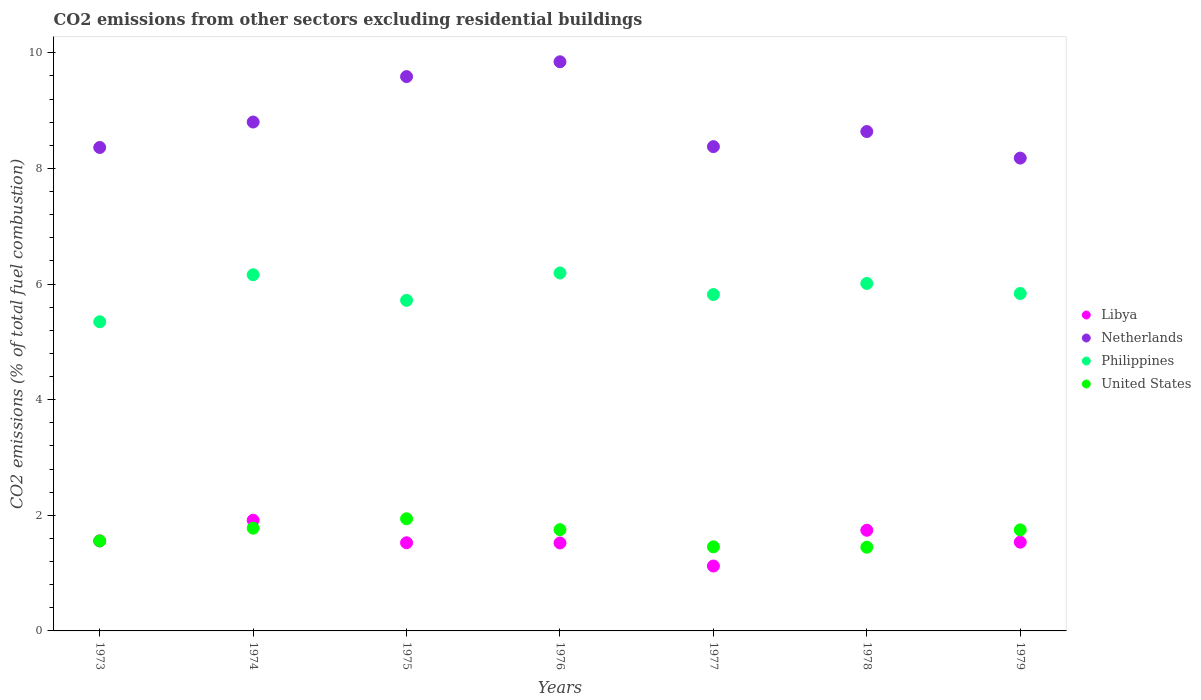Is the number of dotlines equal to the number of legend labels?
Provide a short and direct response. Yes. What is the total CO2 emitted in United States in 1978?
Keep it short and to the point. 1.45. Across all years, what is the maximum total CO2 emitted in Philippines?
Your response must be concise. 6.19. Across all years, what is the minimum total CO2 emitted in United States?
Provide a short and direct response. 1.45. In which year was the total CO2 emitted in Netherlands maximum?
Provide a succinct answer. 1976. What is the total total CO2 emitted in Libya in the graph?
Offer a terse response. 10.92. What is the difference between the total CO2 emitted in Libya in 1974 and that in 1977?
Offer a terse response. 0.79. What is the difference between the total CO2 emitted in Netherlands in 1973 and the total CO2 emitted in Philippines in 1974?
Your answer should be compact. 2.2. What is the average total CO2 emitted in Libya per year?
Offer a very short reply. 1.56. In the year 1974, what is the difference between the total CO2 emitted in Philippines and total CO2 emitted in United States?
Offer a very short reply. 4.38. What is the ratio of the total CO2 emitted in Philippines in 1973 to that in 1976?
Make the answer very short. 0.86. Is the total CO2 emitted in Philippines in 1975 less than that in 1979?
Your answer should be compact. Yes. Is the difference between the total CO2 emitted in Philippines in 1973 and 1975 greater than the difference between the total CO2 emitted in United States in 1973 and 1975?
Your answer should be very brief. Yes. What is the difference between the highest and the second highest total CO2 emitted in United States?
Your response must be concise. 0.16. What is the difference between the highest and the lowest total CO2 emitted in Philippines?
Offer a terse response. 0.84. In how many years, is the total CO2 emitted in Libya greater than the average total CO2 emitted in Libya taken over all years?
Provide a succinct answer. 2. Is the sum of the total CO2 emitted in Libya in 1977 and 1979 greater than the maximum total CO2 emitted in Philippines across all years?
Your response must be concise. No. Is it the case that in every year, the sum of the total CO2 emitted in Netherlands and total CO2 emitted in United States  is greater than the total CO2 emitted in Philippines?
Keep it short and to the point. Yes. Is the total CO2 emitted in Netherlands strictly greater than the total CO2 emitted in United States over the years?
Make the answer very short. Yes. Is the total CO2 emitted in Libya strictly less than the total CO2 emitted in United States over the years?
Offer a terse response. No. Does the graph contain any zero values?
Your response must be concise. No. How are the legend labels stacked?
Offer a terse response. Vertical. What is the title of the graph?
Your response must be concise. CO2 emissions from other sectors excluding residential buildings. What is the label or title of the Y-axis?
Provide a succinct answer. CO2 emissions (% of total fuel combustion). What is the CO2 emissions (% of total fuel combustion) in Libya in 1973?
Ensure brevity in your answer.  1.56. What is the CO2 emissions (% of total fuel combustion) in Netherlands in 1973?
Offer a very short reply. 8.36. What is the CO2 emissions (% of total fuel combustion) in Philippines in 1973?
Your answer should be very brief. 5.35. What is the CO2 emissions (% of total fuel combustion) of United States in 1973?
Offer a terse response. 1.56. What is the CO2 emissions (% of total fuel combustion) of Libya in 1974?
Offer a terse response. 1.91. What is the CO2 emissions (% of total fuel combustion) in Netherlands in 1974?
Ensure brevity in your answer.  8.8. What is the CO2 emissions (% of total fuel combustion) in Philippines in 1974?
Keep it short and to the point. 6.16. What is the CO2 emissions (% of total fuel combustion) in United States in 1974?
Ensure brevity in your answer.  1.78. What is the CO2 emissions (% of total fuel combustion) in Libya in 1975?
Your response must be concise. 1.53. What is the CO2 emissions (% of total fuel combustion) of Netherlands in 1975?
Offer a terse response. 9.59. What is the CO2 emissions (% of total fuel combustion) of Philippines in 1975?
Provide a succinct answer. 5.72. What is the CO2 emissions (% of total fuel combustion) of United States in 1975?
Your response must be concise. 1.94. What is the CO2 emissions (% of total fuel combustion) of Libya in 1976?
Give a very brief answer. 1.52. What is the CO2 emissions (% of total fuel combustion) of Netherlands in 1976?
Your response must be concise. 9.85. What is the CO2 emissions (% of total fuel combustion) of Philippines in 1976?
Provide a succinct answer. 6.19. What is the CO2 emissions (% of total fuel combustion) in United States in 1976?
Your answer should be very brief. 1.75. What is the CO2 emissions (% of total fuel combustion) in Libya in 1977?
Offer a terse response. 1.12. What is the CO2 emissions (% of total fuel combustion) of Netherlands in 1977?
Give a very brief answer. 8.38. What is the CO2 emissions (% of total fuel combustion) in Philippines in 1977?
Offer a terse response. 5.82. What is the CO2 emissions (% of total fuel combustion) of United States in 1977?
Your answer should be very brief. 1.45. What is the CO2 emissions (% of total fuel combustion) of Libya in 1978?
Give a very brief answer. 1.74. What is the CO2 emissions (% of total fuel combustion) in Netherlands in 1978?
Provide a short and direct response. 8.64. What is the CO2 emissions (% of total fuel combustion) in Philippines in 1978?
Make the answer very short. 6.01. What is the CO2 emissions (% of total fuel combustion) of United States in 1978?
Offer a terse response. 1.45. What is the CO2 emissions (% of total fuel combustion) in Libya in 1979?
Keep it short and to the point. 1.54. What is the CO2 emissions (% of total fuel combustion) in Netherlands in 1979?
Give a very brief answer. 8.18. What is the CO2 emissions (% of total fuel combustion) of Philippines in 1979?
Keep it short and to the point. 5.84. What is the CO2 emissions (% of total fuel combustion) of United States in 1979?
Make the answer very short. 1.75. Across all years, what is the maximum CO2 emissions (% of total fuel combustion) of Libya?
Provide a succinct answer. 1.91. Across all years, what is the maximum CO2 emissions (% of total fuel combustion) of Netherlands?
Your response must be concise. 9.85. Across all years, what is the maximum CO2 emissions (% of total fuel combustion) in Philippines?
Your response must be concise. 6.19. Across all years, what is the maximum CO2 emissions (% of total fuel combustion) in United States?
Your answer should be very brief. 1.94. Across all years, what is the minimum CO2 emissions (% of total fuel combustion) of Libya?
Provide a short and direct response. 1.12. Across all years, what is the minimum CO2 emissions (% of total fuel combustion) of Netherlands?
Provide a succinct answer. 8.18. Across all years, what is the minimum CO2 emissions (% of total fuel combustion) of Philippines?
Offer a terse response. 5.35. Across all years, what is the minimum CO2 emissions (% of total fuel combustion) of United States?
Provide a succinct answer. 1.45. What is the total CO2 emissions (% of total fuel combustion) in Libya in the graph?
Offer a terse response. 10.92. What is the total CO2 emissions (% of total fuel combustion) in Netherlands in the graph?
Give a very brief answer. 61.8. What is the total CO2 emissions (% of total fuel combustion) of Philippines in the graph?
Keep it short and to the point. 41.09. What is the total CO2 emissions (% of total fuel combustion) of United States in the graph?
Your response must be concise. 11.68. What is the difference between the CO2 emissions (% of total fuel combustion) of Libya in 1973 and that in 1974?
Give a very brief answer. -0.36. What is the difference between the CO2 emissions (% of total fuel combustion) in Netherlands in 1973 and that in 1974?
Give a very brief answer. -0.44. What is the difference between the CO2 emissions (% of total fuel combustion) of Philippines in 1973 and that in 1974?
Give a very brief answer. -0.81. What is the difference between the CO2 emissions (% of total fuel combustion) in United States in 1973 and that in 1974?
Your answer should be very brief. -0.22. What is the difference between the CO2 emissions (% of total fuel combustion) of Libya in 1973 and that in 1975?
Provide a short and direct response. 0.03. What is the difference between the CO2 emissions (% of total fuel combustion) in Netherlands in 1973 and that in 1975?
Offer a very short reply. -1.23. What is the difference between the CO2 emissions (% of total fuel combustion) in Philippines in 1973 and that in 1975?
Keep it short and to the point. -0.37. What is the difference between the CO2 emissions (% of total fuel combustion) in United States in 1973 and that in 1975?
Ensure brevity in your answer.  -0.38. What is the difference between the CO2 emissions (% of total fuel combustion) of Libya in 1973 and that in 1976?
Your answer should be compact. 0.04. What is the difference between the CO2 emissions (% of total fuel combustion) of Netherlands in 1973 and that in 1976?
Your answer should be compact. -1.48. What is the difference between the CO2 emissions (% of total fuel combustion) in Philippines in 1973 and that in 1976?
Make the answer very short. -0.84. What is the difference between the CO2 emissions (% of total fuel combustion) in United States in 1973 and that in 1976?
Provide a short and direct response. -0.19. What is the difference between the CO2 emissions (% of total fuel combustion) of Libya in 1973 and that in 1977?
Your response must be concise. 0.43. What is the difference between the CO2 emissions (% of total fuel combustion) of Netherlands in 1973 and that in 1977?
Give a very brief answer. -0.01. What is the difference between the CO2 emissions (% of total fuel combustion) in Philippines in 1973 and that in 1977?
Provide a succinct answer. -0.47. What is the difference between the CO2 emissions (% of total fuel combustion) of United States in 1973 and that in 1977?
Keep it short and to the point. 0.1. What is the difference between the CO2 emissions (% of total fuel combustion) in Libya in 1973 and that in 1978?
Your response must be concise. -0.18. What is the difference between the CO2 emissions (% of total fuel combustion) in Netherlands in 1973 and that in 1978?
Your answer should be very brief. -0.28. What is the difference between the CO2 emissions (% of total fuel combustion) of Philippines in 1973 and that in 1978?
Give a very brief answer. -0.66. What is the difference between the CO2 emissions (% of total fuel combustion) of United States in 1973 and that in 1978?
Keep it short and to the point. 0.11. What is the difference between the CO2 emissions (% of total fuel combustion) of Libya in 1973 and that in 1979?
Provide a short and direct response. 0.02. What is the difference between the CO2 emissions (% of total fuel combustion) of Netherlands in 1973 and that in 1979?
Your answer should be compact. 0.18. What is the difference between the CO2 emissions (% of total fuel combustion) in Philippines in 1973 and that in 1979?
Ensure brevity in your answer.  -0.49. What is the difference between the CO2 emissions (% of total fuel combustion) of United States in 1973 and that in 1979?
Keep it short and to the point. -0.19. What is the difference between the CO2 emissions (% of total fuel combustion) of Libya in 1974 and that in 1975?
Offer a terse response. 0.39. What is the difference between the CO2 emissions (% of total fuel combustion) in Netherlands in 1974 and that in 1975?
Your answer should be very brief. -0.79. What is the difference between the CO2 emissions (% of total fuel combustion) of Philippines in 1974 and that in 1975?
Your answer should be very brief. 0.44. What is the difference between the CO2 emissions (% of total fuel combustion) of United States in 1974 and that in 1975?
Provide a short and direct response. -0.16. What is the difference between the CO2 emissions (% of total fuel combustion) of Libya in 1974 and that in 1976?
Your answer should be compact. 0.39. What is the difference between the CO2 emissions (% of total fuel combustion) of Netherlands in 1974 and that in 1976?
Your answer should be very brief. -1.04. What is the difference between the CO2 emissions (% of total fuel combustion) of Philippines in 1974 and that in 1976?
Your response must be concise. -0.03. What is the difference between the CO2 emissions (% of total fuel combustion) of United States in 1974 and that in 1976?
Provide a succinct answer. 0.03. What is the difference between the CO2 emissions (% of total fuel combustion) in Libya in 1974 and that in 1977?
Your response must be concise. 0.79. What is the difference between the CO2 emissions (% of total fuel combustion) in Netherlands in 1974 and that in 1977?
Keep it short and to the point. 0.43. What is the difference between the CO2 emissions (% of total fuel combustion) of Philippines in 1974 and that in 1977?
Give a very brief answer. 0.34. What is the difference between the CO2 emissions (% of total fuel combustion) of United States in 1974 and that in 1977?
Offer a very short reply. 0.32. What is the difference between the CO2 emissions (% of total fuel combustion) of Libya in 1974 and that in 1978?
Ensure brevity in your answer.  0.17. What is the difference between the CO2 emissions (% of total fuel combustion) in Netherlands in 1974 and that in 1978?
Give a very brief answer. 0.16. What is the difference between the CO2 emissions (% of total fuel combustion) of Philippines in 1974 and that in 1978?
Ensure brevity in your answer.  0.15. What is the difference between the CO2 emissions (% of total fuel combustion) of United States in 1974 and that in 1978?
Offer a very short reply. 0.33. What is the difference between the CO2 emissions (% of total fuel combustion) in Libya in 1974 and that in 1979?
Provide a short and direct response. 0.38. What is the difference between the CO2 emissions (% of total fuel combustion) in Netherlands in 1974 and that in 1979?
Give a very brief answer. 0.62. What is the difference between the CO2 emissions (% of total fuel combustion) of Philippines in 1974 and that in 1979?
Keep it short and to the point. 0.32. What is the difference between the CO2 emissions (% of total fuel combustion) of United States in 1974 and that in 1979?
Give a very brief answer. 0.03. What is the difference between the CO2 emissions (% of total fuel combustion) in Libya in 1975 and that in 1976?
Make the answer very short. 0. What is the difference between the CO2 emissions (% of total fuel combustion) of Netherlands in 1975 and that in 1976?
Ensure brevity in your answer.  -0.26. What is the difference between the CO2 emissions (% of total fuel combustion) of Philippines in 1975 and that in 1976?
Your response must be concise. -0.47. What is the difference between the CO2 emissions (% of total fuel combustion) of United States in 1975 and that in 1976?
Keep it short and to the point. 0.19. What is the difference between the CO2 emissions (% of total fuel combustion) of Libya in 1975 and that in 1977?
Give a very brief answer. 0.4. What is the difference between the CO2 emissions (% of total fuel combustion) of Netherlands in 1975 and that in 1977?
Ensure brevity in your answer.  1.21. What is the difference between the CO2 emissions (% of total fuel combustion) of Philippines in 1975 and that in 1977?
Your answer should be very brief. -0.1. What is the difference between the CO2 emissions (% of total fuel combustion) in United States in 1975 and that in 1977?
Your response must be concise. 0.49. What is the difference between the CO2 emissions (% of total fuel combustion) in Libya in 1975 and that in 1978?
Provide a short and direct response. -0.22. What is the difference between the CO2 emissions (% of total fuel combustion) in Netherlands in 1975 and that in 1978?
Provide a short and direct response. 0.95. What is the difference between the CO2 emissions (% of total fuel combustion) in Philippines in 1975 and that in 1978?
Provide a short and direct response. -0.29. What is the difference between the CO2 emissions (% of total fuel combustion) of United States in 1975 and that in 1978?
Keep it short and to the point. 0.49. What is the difference between the CO2 emissions (% of total fuel combustion) in Libya in 1975 and that in 1979?
Provide a succinct answer. -0.01. What is the difference between the CO2 emissions (% of total fuel combustion) of Netherlands in 1975 and that in 1979?
Offer a terse response. 1.41. What is the difference between the CO2 emissions (% of total fuel combustion) of Philippines in 1975 and that in 1979?
Your answer should be compact. -0.12. What is the difference between the CO2 emissions (% of total fuel combustion) of United States in 1975 and that in 1979?
Give a very brief answer. 0.19. What is the difference between the CO2 emissions (% of total fuel combustion) in Libya in 1976 and that in 1977?
Provide a succinct answer. 0.4. What is the difference between the CO2 emissions (% of total fuel combustion) of Netherlands in 1976 and that in 1977?
Offer a very short reply. 1.47. What is the difference between the CO2 emissions (% of total fuel combustion) of Philippines in 1976 and that in 1977?
Provide a succinct answer. 0.37. What is the difference between the CO2 emissions (% of total fuel combustion) in United States in 1976 and that in 1977?
Provide a succinct answer. 0.3. What is the difference between the CO2 emissions (% of total fuel combustion) in Libya in 1976 and that in 1978?
Keep it short and to the point. -0.22. What is the difference between the CO2 emissions (% of total fuel combustion) of Netherlands in 1976 and that in 1978?
Keep it short and to the point. 1.21. What is the difference between the CO2 emissions (% of total fuel combustion) of Philippines in 1976 and that in 1978?
Provide a short and direct response. 0.18. What is the difference between the CO2 emissions (% of total fuel combustion) of United States in 1976 and that in 1978?
Make the answer very short. 0.3. What is the difference between the CO2 emissions (% of total fuel combustion) in Libya in 1976 and that in 1979?
Provide a short and direct response. -0.01. What is the difference between the CO2 emissions (% of total fuel combustion) of Netherlands in 1976 and that in 1979?
Make the answer very short. 1.67. What is the difference between the CO2 emissions (% of total fuel combustion) of Philippines in 1976 and that in 1979?
Offer a terse response. 0.35. What is the difference between the CO2 emissions (% of total fuel combustion) in United States in 1976 and that in 1979?
Provide a short and direct response. 0. What is the difference between the CO2 emissions (% of total fuel combustion) of Libya in 1977 and that in 1978?
Keep it short and to the point. -0.62. What is the difference between the CO2 emissions (% of total fuel combustion) of Netherlands in 1977 and that in 1978?
Provide a short and direct response. -0.26. What is the difference between the CO2 emissions (% of total fuel combustion) of Philippines in 1977 and that in 1978?
Provide a succinct answer. -0.19. What is the difference between the CO2 emissions (% of total fuel combustion) of United States in 1977 and that in 1978?
Offer a very short reply. 0.01. What is the difference between the CO2 emissions (% of total fuel combustion) in Libya in 1977 and that in 1979?
Give a very brief answer. -0.41. What is the difference between the CO2 emissions (% of total fuel combustion) of Netherlands in 1977 and that in 1979?
Your response must be concise. 0.2. What is the difference between the CO2 emissions (% of total fuel combustion) of Philippines in 1977 and that in 1979?
Your response must be concise. -0.02. What is the difference between the CO2 emissions (% of total fuel combustion) of United States in 1977 and that in 1979?
Make the answer very short. -0.29. What is the difference between the CO2 emissions (% of total fuel combustion) in Libya in 1978 and that in 1979?
Ensure brevity in your answer.  0.21. What is the difference between the CO2 emissions (% of total fuel combustion) of Netherlands in 1978 and that in 1979?
Make the answer very short. 0.46. What is the difference between the CO2 emissions (% of total fuel combustion) in Philippines in 1978 and that in 1979?
Your answer should be very brief. 0.17. What is the difference between the CO2 emissions (% of total fuel combustion) in United States in 1978 and that in 1979?
Ensure brevity in your answer.  -0.3. What is the difference between the CO2 emissions (% of total fuel combustion) in Libya in 1973 and the CO2 emissions (% of total fuel combustion) in Netherlands in 1974?
Your answer should be very brief. -7.25. What is the difference between the CO2 emissions (% of total fuel combustion) of Libya in 1973 and the CO2 emissions (% of total fuel combustion) of Philippines in 1974?
Your answer should be compact. -4.6. What is the difference between the CO2 emissions (% of total fuel combustion) in Libya in 1973 and the CO2 emissions (% of total fuel combustion) in United States in 1974?
Provide a succinct answer. -0.22. What is the difference between the CO2 emissions (% of total fuel combustion) of Netherlands in 1973 and the CO2 emissions (% of total fuel combustion) of Philippines in 1974?
Provide a succinct answer. 2.2. What is the difference between the CO2 emissions (% of total fuel combustion) in Netherlands in 1973 and the CO2 emissions (% of total fuel combustion) in United States in 1974?
Keep it short and to the point. 6.59. What is the difference between the CO2 emissions (% of total fuel combustion) of Philippines in 1973 and the CO2 emissions (% of total fuel combustion) of United States in 1974?
Your response must be concise. 3.57. What is the difference between the CO2 emissions (% of total fuel combustion) in Libya in 1973 and the CO2 emissions (% of total fuel combustion) in Netherlands in 1975?
Provide a short and direct response. -8.03. What is the difference between the CO2 emissions (% of total fuel combustion) in Libya in 1973 and the CO2 emissions (% of total fuel combustion) in Philippines in 1975?
Your response must be concise. -4.16. What is the difference between the CO2 emissions (% of total fuel combustion) of Libya in 1973 and the CO2 emissions (% of total fuel combustion) of United States in 1975?
Provide a short and direct response. -0.38. What is the difference between the CO2 emissions (% of total fuel combustion) of Netherlands in 1973 and the CO2 emissions (% of total fuel combustion) of Philippines in 1975?
Provide a succinct answer. 2.65. What is the difference between the CO2 emissions (% of total fuel combustion) in Netherlands in 1973 and the CO2 emissions (% of total fuel combustion) in United States in 1975?
Your response must be concise. 6.42. What is the difference between the CO2 emissions (% of total fuel combustion) in Philippines in 1973 and the CO2 emissions (% of total fuel combustion) in United States in 1975?
Your answer should be very brief. 3.41. What is the difference between the CO2 emissions (% of total fuel combustion) in Libya in 1973 and the CO2 emissions (% of total fuel combustion) in Netherlands in 1976?
Keep it short and to the point. -8.29. What is the difference between the CO2 emissions (% of total fuel combustion) of Libya in 1973 and the CO2 emissions (% of total fuel combustion) of Philippines in 1976?
Your response must be concise. -4.63. What is the difference between the CO2 emissions (% of total fuel combustion) in Libya in 1973 and the CO2 emissions (% of total fuel combustion) in United States in 1976?
Ensure brevity in your answer.  -0.19. What is the difference between the CO2 emissions (% of total fuel combustion) in Netherlands in 1973 and the CO2 emissions (% of total fuel combustion) in Philippines in 1976?
Make the answer very short. 2.17. What is the difference between the CO2 emissions (% of total fuel combustion) of Netherlands in 1973 and the CO2 emissions (% of total fuel combustion) of United States in 1976?
Provide a succinct answer. 6.61. What is the difference between the CO2 emissions (% of total fuel combustion) in Philippines in 1973 and the CO2 emissions (% of total fuel combustion) in United States in 1976?
Keep it short and to the point. 3.6. What is the difference between the CO2 emissions (% of total fuel combustion) in Libya in 1973 and the CO2 emissions (% of total fuel combustion) in Netherlands in 1977?
Provide a succinct answer. -6.82. What is the difference between the CO2 emissions (% of total fuel combustion) in Libya in 1973 and the CO2 emissions (% of total fuel combustion) in Philippines in 1977?
Your answer should be compact. -4.26. What is the difference between the CO2 emissions (% of total fuel combustion) of Libya in 1973 and the CO2 emissions (% of total fuel combustion) of United States in 1977?
Give a very brief answer. 0.1. What is the difference between the CO2 emissions (% of total fuel combustion) of Netherlands in 1973 and the CO2 emissions (% of total fuel combustion) of Philippines in 1977?
Your response must be concise. 2.54. What is the difference between the CO2 emissions (% of total fuel combustion) in Netherlands in 1973 and the CO2 emissions (% of total fuel combustion) in United States in 1977?
Provide a short and direct response. 6.91. What is the difference between the CO2 emissions (% of total fuel combustion) in Philippines in 1973 and the CO2 emissions (% of total fuel combustion) in United States in 1977?
Your answer should be compact. 3.89. What is the difference between the CO2 emissions (% of total fuel combustion) in Libya in 1973 and the CO2 emissions (% of total fuel combustion) in Netherlands in 1978?
Provide a short and direct response. -7.08. What is the difference between the CO2 emissions (% of total fuel combustion) of Libya in 1973 and the CO2 emissions (% of total fuel combustion) of Philippines in 1978?
Keep it short and to the point. -4.45. What is the difference between the CO2 emissions (% of total fuel combustion) in Libya in 1973 and the CO2 emissions (% of total fuel combustion) in United States in 1978?
Provide a short and direct response. 0.11. What is the difference between the CO2 emissions (% of total fuel combustion) of Netherlands in 1973 and the CO2 emissions (% of total fuel combustion) of Philippines in 1978?
Your response must be concise. 2.35. What is the difference between the CO2 emissions (% of total fuel combustion) in Netherlands in 1973 and the CO2 emissions (% of total fuel combustion) in United States in 1978?
Offer a terse response. 6.92. What is the difference between the CO2 emissions (% of total fuel combustion) in Libya in 1973 and the CO2 emissions (% of total fuel combustion) in Netherlands in 1979?
Your answer should be compact. -6.62. What is the difference between the CO2 emissions (% of total fuel combustion) of Libya in 1973 and the CO2 emissions (% of total fuel combustion) of Philippines in 1979?
Your response must be concise. -4.28. What is the difference between the CO2 emissions (% of total fuel combustion) in Libya in 1973 and the CO2 emissions (% of total fuel combustion) in United States in 1979?
Offer a very short reply. -0.19. What is the difference between the CO2 emissions (% of total fuel combustion) of Netherlands in 1973 and the CO2 emissions (% of total fuel combustion) of Philippines in 1979?
Provide a succinct answer. 2.53. What is the difference between the CO2 emissions (% of total fuel combustion) in Netherlands in 1973 and the CO2 emissions (% of total fuel combustion) in United States in 1979?
Provide a succinct answer. 6.62. What is the difference between the CO2 emissions (% of total fuel combustion) in Philippines in 1973 and the CO2 emissions (% of total fuel combustion) in United States in 1979?
Offer a very short reply. 3.6. What is the difference between the CO2 emissions (% of total fuel combustion) in Libya in 1974 and the CO2 emissions (% of total fuel combustion) in Netherlands in 1975?
Offer a terse response. -7.67. What is the difference between the CO2 emissions (% of total fuel combustion) of Libya in 1974 and the CO2 emissions (% of total fuel combustion) of Philippines in 1975?
Provide a short and direct response. -3.8. What is the difference between the CO2 emissions (% of total fuel combustion) in Libya in 1974 and the CO2 emissions (% of total fuel combustion) in United States in 1975?
Offer a terse response. -0.03. What is the difference between the CO2 emissions (% of total fuel combustion) in Netherlands in 1974 and the CO2 emissions (% of total fuel combustion) in Philippines in 1975?
Your answer should be compact. 3.09. What is the difference between the CO2 emissions (% of total fuel combustion) in Netherlands in 1974 and the CO2 emissions (% of total fuel combustion) in United States in 1975?
Provide a short and direct response. 6.86. What is the difference between the CO2 emissions (% of total fuel combustion) in Philippines in 1974 and the CO2 emissions (% of total fuel combustion) in United States in 1975?
Give a very brief answer. 4.22. What is the difference between the CO2 emissions (% of total fuel combustion) in Libya in 1974 and the CO2 emissions (% of total fuel combustion) in Netherlands in 1976?
Provide a short and direct response. -7.93. What is the difference between the CO2 emissions (% of total fuel combustion) of Libya in 1974 and the CO2 emissions (% of total fuel combustion) of Philippines in 1976?
Keep it short and to the point. -4.28. What is the difference between the CO2 emissions (% of total fuel combustion) in Libya in 1974 and the CO2 emissions (% of total fuel combustion) in United States in 1976?
Offer a terse response. 0.16. What is the difference between the CO2 emissions (% of total fuel combustion) of Netherlands in 1974 and the CO2 emissions (% of total fuel combustion) of Philippines in 1976?
Give a very brief answer. 2.61. What is the difference between the CO2 emissions (% of total fuel combustion) of Netherlands in 1974 and the CO2 emissions (% of total fuel combustion) of United States in 1976?
Your response must be concise. 7.05. What is the difference between the CO2 emissions (% of total fuel combustion) of Philippines in 1974 and the CO2 emissions (% of total fuel combustion) of United States in 1976?
Make the answer very short. 4.41. What is the difference between the CO2 emissions (% of total fuel combustion) of Libya in 1974 and the CO2 emissions (% of total fuel combustion) of Netherlands in 1977?
Provide a succinct answer. -6.46. What is the difference between the CO2 emissions (% of total fuel combustion) in Libya in 1974 and the CO2 emissions (% of total fuel combustion) in Philippines in 1977?
Offer a terse response. -3.9. What is the difference between the CO2 emissions (% of total fuel combustion) of Libya in 1974 and the CO2 emissions (% of total fuel combustion) of United States in 1977?
Make the answer very short. 0.46. What is the difference between the CO2 emissions (% of total fuel combustion) in Netherlands in 1974 and the CO2 emissions (% of total fuel combustion) in Philippines in 1977?
Give a very brief answer. 2.98. What is the difference between the CO2 emissions (% of total fuel combustion) in Netherlands in 1974 and the CO2 emissions (% of total fuel combustion) in United States in 1977?
Your answer should be very brief. 7.35. What is the difference between the CO2 emissions (% of total fuel combustion) in Philippines in 1974 and the CO2 emissions (% of total fuel combustion) in United States in 1977?
Your answer should be compact. 4.71. What is the difference between the CO2 emissions (% of total fuel combustion) of Libya in 1974 and the CO2 emissions (% of total fuel combustion) of Netherlands in 1978?
Ensure brevity in your answer.  -6.72. What is the difference between the CO2 emissions (% of total fuel combustion) in Libya in 1974 and the CO2 emissions (% of total fuel combustion) in Philippines in 1978?
Provide a succinct answer. -4.1. What is the difference between the CO2 emissions (% of total fuel combustion) in Libya in 1974 and the CO2 emissions (% of total fuel combustion) in United States in 1978?
Ensure brevity in your answer.  0.47. What is the difference between the CO2 emissions (% of total fuel combustion) of Netherlands in 1974 and the CO2 emissions (% of total fuel combustion) of Philippines in 1978?
Provide a succinct answer. 2.79. What is the difference between the CO2 emissions (% of total fuel combustion) in Netherlands in 1974 and the CO2 emissions (% of total fuel combustion) in United States in 1978?
Your answer should be compact. 7.36. What is the difference between the CO2 emissions (% of total fuel combustion) of Philippines in 1974 and the CO2 emissions (% of total fuel combustion) of United States in 1978?
Keep it short and to the point. 4.71. What is the difference between the CO2 emissions (% of total fuel combustion) in Libya in 1974 and the CO2 emissions (% of total fuel combustion) in Netherlands in 1979?
Give a very brief answer. -6.26. What is the difference between the CO2 emissions (% of total fuel combustion) of Libya in 1974 and the CO2 emissions (% of total fuel combustion) of Philippines in 1979?
Provide a short and direct response. -3.92. What is the difference between the CO2 emissions (% of total fuel combustion) in Libya in 1974 and the CO2 emissions (% of total fuel combustion) in United States in 1979?
Give a very brief answer. 0.17. What is the difference between the CO2 emissions (% of total fuel combustion) in Netherlands in 1974 and the CO2 emissions (% of total fuel combustion) in Philippines in 1979?
Your answer should be compact. 2.97. What is the difference between the CO2 emissions (% of total fuel combustion) in Netherlands in 1974 and the CO2 emissions (% of total fuel combustion) in United States in 1979?
Your answer should be compact. 7.06. What is the difference between the CO2 emissions (% of total fuel combustion) of Philippines in 1974 and the CO2 emissions (% of total fuel combustion) of United States in 1979?
Ensure brevity in your answer.  4.41. What is the difference between the CO2 emissions (% of total fuel combustion) in Libya in 1975 and the CO2 emissions (% of total fuel combustion) in Netherlands in 1976?
Your answer should be compact. -8.32. What is the difference between the CO2 emissions (% of total fuel combustion) in Libya in 1975 and the CO2 emissions (% of total fuel combustion) in Philippines in 1976?
Your answer should be very brief. -4.67. What is the difference between the CO2 emissions (% of total fuel combustion) of Libya in 1975 and the CO2 emissions (% of total fuel combustion) of United States in 1976?
Ensure brevity in your answer.  -0.23. What is the difference between the CO2 emissions (% of total fuel combustion) in Netherlands in 1975 and the CO2 emissions (% of total fuel combustion) in Philippines in 1976?
Provide a succinct answer. 3.4. What is the difference between the CO2 emissions (% of total fuel combustion) in Netherlands in 1975 and the CO2 emissions (% of total fuel combustion) in United States in 1976?
Your answer should be compact. 7.84. What is the difference between the CO2 emissions (% of total fuel combustion) in Philippines in 1975 and the CO2 emissions (% of total fuel combustion) in United States in 1976?
Give a very brief answer. 3.97. What is the difference between the CO2 emissions (% of total fuel combustion) of Libya in 1975 and the CO2 emissions (% of total fuel combustion) of Netherlands in 1977?
Provide a succinct answer. -6.85. What is the difference between the CO2 emissions (% of total fuel combustion) of Libya in 1975 and the CO2 emissions (% of total fuel combustion) of Philippines in 1977?
Your answer should be very brief. -4.29. What is the difference between the CO2 emissions (% of total fuel combustion) of Libya in 1975 and the CO2 emissions (% of total fuel combustion) of United States in 1977?
Provide a short and direct response. 0.07. What is the difference between the CO2 emissions (% of total fuel combustion) of Netherlands in 1975 and the CO2 emissions (% of total fuel combustion) of Philippines in 1977?
Your answer should be compact. 3.77. What is the difference between the CO2 emissions (% of total fuel combustion) of Netherlands in 1975 and the CO2 emissions (% of total fuel combustion) of United States in 1977?
Offer a terse response. 8.13. What is the difference between the CO2 emissions (% of total fuel combustion) in Philippines in 1975 and the CO2 emissions (% of total fuel combustion) in United States in 1977?
Your answer should be very brief. 4.26. What is the difference between the CO2 emissions (% of total fuel combustion) of Libya in 1975 and the CO2 emissions (% of total fuel combustion) of Netherlands in 1978?
Provide a succinct answer. -7.11. What is the difference between the CO2 emissions (% of total fuel combustion) in Libya in 1975 and the CO2 emissions (% of total fuel combustion) in Philippines in 1978?
Your answer should be very brief. -4.49. What is the difference between the CO2 emissions (% of total fuel combustion) in Libya in 1975 and the CO2 emissions (% of total fuel combustion) in United States in 1978?
Provide a succinct answer. 0.08. What is the difference between the CO2 emissions (% of total fuel combustion) of Netherlands in 1975 and the CO2 emissions (% of total fuel combustion) of Philippines in 1978?
Your answer should be compact. 3.58. What is the difference between the CO2 emissions (% of total fuel combustion) in Netherlands in 1975 and the CO2 emissions (% of total fuel combustion) in United States in 1978?
Ensure brevity in your answer.  8.14. What is the difference between the CO2 emissions (% of total fuel combustion) of Philippines in 1975 and the CO2 emissions (% of total fuel combustion) of United States in 1978?
Your answer should be compact. 4.27. What is the difference between the CO2 emissions (% of total fuel combustion) in Libya in 1975 and the CO2 emissions (% of total fuel combustion) in Netherlands in 1979?
Your response must be concise. -6.65. What is the difference between the CO2 emissions (% of total fuel combustion) in Libya in 1975 and the CO2 emissions (% of total fuel combustion) in Philippines in 1979?
Provide a short and direct response. -4.31. What is the difference between the CO2 emissions (% of total fuel combustion) in Libya in 1975 and the CO2 emissions (% of total fuel combustion) in United States in 1979?
Make the answer very short. -0.22. What is the difference between the CO2 emissions (% of total fuel combustion) of Netherlands in 1975 and the CO2 emissions (% of total fuel combustion) of Philippines in 1979?
Provide a short and direct response. 3.75. What is the difference between the CO2 emissions (% of total fuel combustion) of Netherlands in 1975 and the CO2 emissions (% of total fuel combustion) of United States in 1979?
Provide a succinct answer. 7.84. What is the difference between the CO2 emissions (% of total fuel combustion) of Philippines in 1975 and the CO2 emissions (% of total fuel combustion) of United States in 1979?
Make the answer very short. 3.97. What is the difference between the CO2 emissions (% of total fuel combustion) of Libya in 1976 and the CO2 emissions (% of total fuel combustion) of Netherlands in 1977?
Offer a very short reply. -6.86. What is the difference between the CO2 emissions (% of total fuel combustion) in Libya in 1976 and the CO2 emissions (% of total fuel combustion) in Philippines in 1977?
Offer a very short reply. -4.3. What is the difference between the CO2 emissions (% of total fuel combustion) of Libya in 1976 and the CO2 emissions (% of total fuel combustion) of United States in 1977?
Offer a terse response. 0.07. What is the difference between the CO2 emissions (% of total fuel combustion) in Netherlands in 1976 and the CO2 emissions (% of total fuel combustion) in Philippines in 1977?
Offer a very short reply. 4.03. What is the difference between the CO2 emissions (% of total fuel combustion) in Netherlands in 1976 and the CO2 emissions (% of total fuel combustion) in United States in 1977?
Provide a succinct answer. 8.39. What is the difference between the CO2 emissions (% of total fuel combustion) in Philippines in 1976 and the CO2 emissions (% of total fuel combustion) in United States in 1977?
Your response must be concise. 4.74. What is the difference between the CO2 emissions (% of total fuel combustion) of Libya in 1976 and the CO2 emissions (% of total fuel combustion) of Netherlands in 1978?
Keep it short and to the point. -7.12. What is the difference between the CO2 emissions (% of total fuel combustion) in Libya in 1976 and the CO2 emissions (% of total fuel combustion) in Philippines in 1978?
Offer a very short reply. -4.49. What is the difference between the CO2 emissions (% of total fuel combustion) in Libya in 1976 and the CO2 emissions (% of total fuel combustion) in United States in 1978?
Offer a terse response. 0.07. What is the difference between the CO2 emissions (% of total fuel combustion) in Netherlands in 1976 and the CO2 emissions (% of total fuel combustion) in Philippines in 1978?
Provide a short and direct response. 3.83. What is the difference between the CO2 emissions (% of total fuel combustion) in Netherlands in 1976 and the CO2 emissions (% of total fuel combustion) in United States in 1978?
Your answer should be compact. 8.4. What is the difference between the CO2 emissions (% of total fuel combustion) in Philippines in 1976 and the CO2 emissions (% of total fuel combustion) in United States in 1978?
Your response must be concise. 4.74. What is the difference between the CO2 emissions (% of total fuel combustion) of Libya in 1976 and the CO2 emissions (% of total fuel combustion) of Netherlands in 1979?
Keep it short and to the point. -6.66. What is the difference between the CO2 emissions (% of total fuel combustion) of Libya in 1976 and the CO2 emissions (% of total fuel combustion) of Philippines in 1979?
Keep it short and to the point. -4.32. What is the difference between the CO2 emissions (% of total fuel combustion) of Libya in 1976 and the CO2 emissions (% of total fuel combustion) of United States in 1979?
Offer a very short reply. -0.23. What is the difference between the CO2 emissions (% of total fuel combustion) of Netherlands in 1976 and the CO2 emissions (% of total fuel combustion) of Philippines in 1979?
Offer a terse response. 4.01. What is the difference between the CO2 emissions (% of total fuel combustion) in Netherlands in 1976 and the CO2 emissions (% of total fuel combustion) in United States in 1979?
Offer a very short reply. 8.1. What is the difference between the CO2 emissions (% of total fuel combustion) of Philippines in 1976 and the CO2 emissions (% of total fuel combustion) of United States in 1979?
Offer a terse response. 4.44. What is the difference between the CO2 emissions (% of total fuel combustion) in Libya in 1977 and the CO2 emissions (% of total fuel combustion) in Netherlands in 1978?
Keep it short and to the point. -7.52. What is the difference between the CO2 emissions (% of total fuel combustion) of Libya in 1977 and the CO2 emissions (% of total fuel combustion) of Philippines in 1978?
Provide a succinct answer. -4.89. What is the difference between the CO2 emissions (% of total fuel combustion) of Libya in 1977 and the CO2 emissions (% of total fuel combustion) of United States in 1978?
Provide a succinct answer. -0.33. What is the difference between the CO2 emissions (% of total fuel combustion) in Netherlands in 1977 and the CO2 emissions (% of total fuel combustion) in Philippines in 1978?
Ensure brevity in your answer.  2.37. What is the difference between the CO2 emissions (% of total fuel combustion) of Netherlands in 1977 and the CO2 emissions (% of total fuel combustion) of United States in 1978?
Your answer should be very brief. 6.93. What is the difference between the CO2 emissions (% of total fuel combustion) of Philippines in 1977 and the CO2 emissions (% of total fuel combustion) of United States in 1978?
Your answer should be compact. 4.37. What is the difference between the CO2 emissions (% of total fuel combustion) in Libya in 1977 and the CO2 emissions (% of total fuel combustion) in Netherlands in 1979?
Offer a terse response. -7.06. What is the difference between the CO2 emissions (% of total fuel combustion) of Libya in 1977 and the CO2 emissions (% of total fuel combustion) of Philippines in 1979?
Make the answer very short. -4.71. What is the difference between the CO2 emissions (% of total fuel combustion) in Libya in 1977 and the CO2 emissions (% of total fuel combustion) in United States in 1979?
Your response must be concise. -0.63. What is the difference between the CO2 emissions (% of total fuel combustion) of Netherlands in 1977 and the CO2 emissions (% of total fuel combustion) of Philippines in 1979?
Offer a very short reply. 2.54. What is the difference between the CO2 emissions (% of total fuel combustion) in Netherlands in 1977 and the CO2 emissions (% of total fuel combustion) in United States in 1979?
Ensure brevity in your answer.  6.63. What is the difference between the CO2 emissions (% of total fuel combustion) in Philippines in 1977 and the CO2 emissions (% of total fuel combustion) in United States in 1979?
Provide a succinct answer. 4.07. What is the difference between the CO2 emissions (% of total fuel combustion) of Libya in 1978 and the CO2 emissions (% of total fuel combustion) of Netherlands in 1979?
Provide a short and direct response. -6.44. What is the difference between the CO2 emissions (% of total fuel combustion) in Libya in 1978 and the CO2 emissions (% of total fuel combustion) in Philippines in 1979?
Offer a very short reply. -4.1. What is the difference between the CO2 emissions (% of total fuel combustion) of Libya in 1978 and the CO2 emissions (% of total fuel combustion) of United States in 1979?
Give a very brief answer. -0.01. What is the difference between the CO2 emissions (% of total fuel combustion) of Netherlands in 1978 and the CO2 emissions (% of total fuel combustion) of Philippines in 1979?
Keep it short and to the point. 2.8. What is the difference between the CO2 emissions (% of total fuel combustion) of Netherlands in 1978 and the CO2 emissions (% of total fuel combustion) of United States in 1979?
Your response must be concise. 6.89. What is the difference between the CO2 emissions (% of total fuel combustion) in Philippines in 1978 and the CO2 emissions (% of total fuel combustion) in United States in 1979?
Offer a very short reply. 4.26. What is the average CO2 emissions (% of total fuel combustion) of Libya per year?
Your answer should be very brief. 1.56. What is the average CO2 emissions (% of total fuel combustion) of Netherlands per year?
Your response must be concise. 8.83. What is the average CO2 emissions (% of total fuel combustion) of Philippines per year?
Provide a succinct answer. 5.87. What is the average CO2 emissions (% of total fuel combustion) in United States per year?
Provide a succinct answer. 1.67. In the year 1973, what is the difference between the CO2 emissions (% of total fuel combustion) in Libya and CO2 emissions (% of total fuel combustion) in Netherlands?
Your response must be concise. -6.81. In the year 1973, what is the difference between the CO2 emissions (% of total fuel combustion) of Libya and CO2 emissions (% of total fuel combustion) of Philippines?
Give a very brief answer. -3.79. In the year 1973, what is the difference between the CO2 emissions (% of total fuel combustion) of Libya and CO2 emissions (% of total fuel combustion) of United States?
Offer a terse response. 0. In the year 1973, what is the difference between the CO2 emissions (% of total fuel combustion) of Netherlands and CO2 emissions (% of total fuel combustion) of Philippines?
Offer a terse response. 3.02. In the year 1973, what is the difference between the CO2 emissions (% of total fuel combustion) of Netherlands and CO2 emissions (% of total fuel combustion) of United States?
Provide a succinct answer. 6.81. In the year 1973, what is the difference between the CO2 emissions (% of total fuel combustion) of Philippines and CO2 emissions (% of total fuel combustion) of United States?
Your answer should be compact. 3.79. In the year 1974, what is the difference between the CO2 emissions (% of total fuel combustion) in Libya and CO2 emissions (% of total fuel combustion) in Netherlands?
Give a very brief answer. -6.89. In the year 1974, what is the difference between the CO2 emissions (% of total fuel combustion) in Libya and CO2 emissions (% of total fuel combustion) in Philippines?
Give a very brief answer. -4.25. In the year 1974, what is the difference between the CO2 emissions (% of total fuel combustion) of Libya and CO2 emissions (% of total fuel combustion) of United States?
Your response must be concise. 0.14. In the year 1974, what is the difference between the CO2 emissions (% of total fuel combustion) in Netherlands and CO2 emissions (% of total fuel combustion) in Philippines?
Your response must be concise. 2.64. In the year 1974, what is the difference between the CO2 emissions (% of total fuel combustion) of Netherlands and CO2 emissions (% of total fuel combustion) of United States?
Provide a short and direct response. 7.03. In the year 1974, what is the difference between the CO2 emissions (% of total fuel combustion) in Philippines and CO2 emissions (% of total fuel combustion) in United States?
Make the answer very short. 4.38. In the year 1975, what is the difference between the CO2 emissions (% of total fuel combustion) of Libya and CO2 emissions (% of total fuel combustion) of Netherlands?
Ensure brevity in your answer.  -8.06. In the year 1975, what is the difference between the CO2 emissions (% of total fuel combustion) of Libya and CO2 emissions (% of total fuel combustion) of Philippines?
Your answer should be compact. -4.19. In the year 1975, what is the difference between the CO2 emissions (% of total fuel combustion) in Libya and CO2 emissions (% of total fuel combustion) in United States?
Keep it short and to the point. -0.42. In the year 1975, what is the difference between the CO2 emissions (% of total fuel combustion) of Netherlands and CO2 emissions (% of total fuel combustion) of Philippines?
Give a very brief answer. 3.87. In the year 1975, what is the difference between the CO2 emissions (% of total fuel combustion) in Netherlands and CO2 emissions (% of total fuel combustion) in United States?
Offer a very short reply. 7.65. In the year 1975, what is the difference between the CO2 emissions (% of total fuel combustion) of Philippines and CO2 emissions (% of total fuel combustion) of United States?
Your answer should be compact. 3.78. In the year 1976, what is the difference between the CO2 emissions (% of total fuel combustion) in Libya and CO2 emissions (% of total fuel combustion) in Netherlands?
Your answer should be very brief. -8.32. In the year 1976, what is the difference between the CO2 emissions (% of total fuel combustion) in Libya and CO2 emissions (% of total fuel combustion) in Philippines?
Make the answer very short. -4.67. In the year 1976, what is the difference between the CO2 emissions (% of total fuel combustion) of Libya and CO2 emissions (% of total fuel combustion) of United States?
Provide a short and direct response. -0.23. In the year 1976, what is the difference between the CO2 emissions (% of total fuel combustion) of Netherlands and CO2 emissions (% of total fuel combustion) of Philippines?
Ensure brevity in your answer.  3.65. In the year 1976, what is the difference between the CO2 emissions (% of total fuel combustion) in Netherlands and CO2 emissions (% of total fuel combustion) in United States?
Offer a very short reply. 8.09. In the year 1976, what is the difference between the CO2 emissions (% of total fuel combustion) in Philippines and CO2 emissions (% of total fuel combustion) in United States?
Make the answer very short. 4.44. In the year 1977, what is the difference between the CO2 emissions (% of total fuel combustion) in Libya and CO2 emissions (% of total fuel combustion) in Netherlands?
Your answer should be very brief. -7.26. In the year 1977, what is the difference between the CO2 emissions (% of total fuel combustion) in Libya and CO2 emissions (% of total fuel combustion) in Philippines?
Offer a terse response. -4.7. In the year 1977, what is the difference between the CO2 emissions (% of total fuel combustion) of Libya and CO2 emissions (% of total fuel combustion) of United States?
Your answer should be very brief. -0.33. In the year 1977, what is the difference between the CO2 emissions (% of total fuel combustion) in Netherlands and CO2 emissions (% of total fuel combustion) in Philippines?
Your answer should be compact. 2.56. In the year 1977, what is the difference between the CO2 emissions (% of total fuel combustion) of Netherlands and CO2 emissions (% of total fuel combustion) of United States?
Offer a very short reply. 6.92. In the year 1977, what is the difference between the CO2 emissions (% of total fuel combustion) in Philippines and CO2 emissions (% of total fuel combustion) in United States?
Make the answer very short. 4.36. In the year 1978, what is the difference between the CO2 emissions (% of total fuel combustion) of Libya and CO2 emissions (% of total fuel combustion) of Netherlands?
Provide a short and direct response. -6.9. In the year 1978, what is the difference between the CO2 emissions (% of total fuel combustion) of Libya and CO2 emissions (% of total fuel combustion) of Philippines?
Your response must be concise. -4.27. In the year 1978, what is the difference between the CO2 emissions (% of total fuel combustion) in Libya and CO2 emissions (% of total fuel combustion) in United States?
Your answer should be very brief. 0.29. In the year 1978, what is the difference between the CO2 emissions (% of total fuel combustion) of Netherlands and CO2 emissions (% of total fuel combustion) of Philippines?
Make the answer very short. 2.63. In the year 1978, what is the difference between the CO2 emissions (% of total fuel combustion) in Netherlands and CO2 emissions (% of total fuel combustion) in United States?
Make the answer very short. 7.19. In the year 1978, what is the difference between the CO2 emissions (% of total fuel combustion) in Philippines and CO2 emissions (% of total fuel combustion) in United States?
Keep it short and to the point. 4.56. In the year 1979, what is the difference between the CO2 emissions (% of total fuel combustion) in Libya and CO2 emissions (% of total fuel combustion) in Netherlands?
Ensure brevity in your answer.  -6.64. In the year 1979, what is the difference between the CO2 emissions (% of total fuel combustion) of Libya and CO2 emissions (% of total fuel combustion) of Philippines?
Offer a terse response. -4.3. In the year 1979, what is the difference between the CO2 emissions (% of total fuel combustion) in Libya and CO2 emissions (% of total fuel combustion) in United States?
Your answer should be very brief. -0.21. In the year 1979, what is the difference between the CO2 emissions (% of total fuel combustion) in Netherlands and CO2 emissions (% of total fuel combustion) in Philippines?
Offer a very short reply. 2.34. In the year 1979, what is the difference between the CO2 emissions (% of total fuel combustion) of Netherlands and CO2 emissions (% of total fuel combustion) of United States?
Your response must be concise. 6.43. In the year 1979, what is the difference between the CO2 emissions (% of total fuel combustion) in Philippines and CO2 emissions (% of total fuel combustion) in United States?
Make the answer very short. 4.09. What is the ratio of the CO2 emissions (% of total fuel combustion) in Libya in 1973 to that in 1974?
Give a very brief answer. 0.81. What is the ratio of the CO2 emissions (% of total fuel combustion) of Netherlands in 1973 to that in 1974?
Ensure brevity in your answer.  0.95. What is the ratio of the CO2 emissions (% of total fuel combustion) in Philippines in 1973 to that in 1974?
Keep it short and to the point. 0.87. What is the ratio of the CO2 emissions (% of total fuel combustion) in United States in 1973 to that in 1974?
Your answer should be compact. 0.88. What is the ratio of the CO2 emissions (% of total fuel combustion) of Netherlands in 1973 to that in 1975?
Keep it short and to the point. 0.87. What is the ratio of the CO2 emissions (% of total fuel combustion) in Philippines in 1973 to that in 1975?
Provide a short and direct response. 0.94. What is the ratio of the CO2 emissions (% of total fuel combustion) of United States in 1973 to that in 1975?
Provide a short and direct response. 0.8. What is the ratio of the CO2 emissions (% of total fuel combustion) in Libya in 1973 to that in 1976?
Provide a short and direct response. 1.02. What is the ratio of the CO2 emissions (% of total fuel combustion) of Netherlands in 1973 to that in 1976?
Give a very brief answer. 0.85. What is the ratio of the CO2 emissions (% of total fuel combustion) in Philippines in 1973 to that in 1976?
Your answer should be compact. 0.86. What is the ratio of the CO2 emissions (% of total fuel combustion) of United States in 1973 to that in 1976?
Make the answer very short. 0.89. What is the ratio of the CO2 emissions (% of total fuel combustion) in Libya in 1973 to that in 1977?
Give a very brief answer. 1.39. What is the ratio of the CO2 emissions (% of total fuel combustion) in Netherlands in 1973 to that in 1977?
Offer a terse response. 1. What is the ratio of the CO2 emissions (% of total fuel combustion) of Philippines in 1973 to that in 1977?
Make the answer very short. 0.92. What is the ratio of the CO2 emissions (% of total fuel combustion) in United States in 1973 to that in 1977?
Make the answer very short. 1.07. What is the ratio of the CO2 emissions (% of total fuel combustion) in Libya in 1973 to that in 1978?
Offer a terse response. 0.89. What is the ratio of the CO2 emissions (% of total fuel combustion) of Netherlands in 1973 to that in 1978?
Give a very brief answer. 0.97. What is the ratio of the CO2 emissions (% of total fuel combustion) in Philippines in 1973 to that in 1978?
Offer a very short reply. 0.89. What is the ratio of the CO2 emissions (% of total fuel combustion) of United States in 1973 to that in 1978?
Offer a terse response. 1.07. What is the ratio of the CO2 emissions (% of total fuel combustion) of Libya in 1973 to that in 1979?
Offer a very short reply. 1.01. What is the ratio of the CO2 emissions (% of total fuel combustion) in Netherlands in 1973 to that in 1979?
Offer a very short reply. 1.02. What is the ratio of the CO2 emissions (% of total fuel combustion) of Philippines in 1973 to that in 1979?
Your answer should be compact. 0.92. What is the ratio of the CO2 emissions (% of total fuel combustion) of United States in 1973 to that in 1979?
Offer a terse response. 0.89. What is the ratio of the CO2 emissions (% of total fuel combustion) in Libya in 1974 to that in 1975?
Give a very brief answer. 1.26. What is the ratio of the CO2 emissions (% of total fuel combustion) in Netherlands in 1974 to that in 1975?
Offer a very short reply. 0.92. What is the ratio of the CO2 emissions (% of total fuel combustion) in Philippines in 1974 to that in 1975?
Your answer should be very brief. 1.08. What is the ratio of the CO2 emissions (% of total fuel combustion) in United States in 1974 to that in 1975?
Offer a very short reply. 0.92. What is the ratio of the CO2 emissions (% of total fuel combustion) in Libya in 1974 to that in 1976?
Give a very brief answer. 1.26. What is the ratio of the CO2 emissions (% of total fuel combustion) of Netherlands in 1974 to that in 1976?
Provide a succinct answer. 0.89. What is the ratio of the CO2 emissions (% of total fuel combustion) in Philippines in 1974 to that in 1976?
Provide a succinct answer. 1. What is the ratio of the CO2 emissions (% of total fuel combustion) of United States in 1974 to that in 1976?
Keep it short and to the point. 1.01. What is the ratio of the CO2 emissions (% of total fuel combustion) in Libya in 1974 to that in 1977?
Your answer should be very brief. 1.71. What is the ratio of the CO2 emissions (% of total fuel combustion) in Netherlands in 1974 to that in 1977?
Your answer should be very brief. 1.05. What is the ratio of the CO2 emissions (% of total fuel combustion) in Philippines in 1974 to that in 1977?
Offer a terse response. 1.06. What is the ratio of the CO2 emissions (% of total fuel combustion) in United States in 1974 to that in 1977?
Offer a very short reply. 1.22. What is the ratio of the CO2 emissions (% of total fuel combustion) of Libya in 1974 to that in 1978?
Keep it short and to the point. 1.1. What is the ratio of the CO2 emissions (% of total fuel combustion) of Netherlands in 1974 to that in 1978?
Provide a succinct answer. 1.02. What is the ratio of the CO2 emissions (% of total fuel combustion) of Philippines in 1974 to that in 1978?
Make the answer very short. 1.03. What is the ratio of the CO2 emissions (% of total fuel combustion) of United States in 1974 to that in 1978?
Make the answer very short. 1.23. What is the ratio of the CO2 emissions (% of total fuel combustion) in Libya in 1974 to that in 1979?
Keep it short and to the point. 1.25. What is the ratio of the CO2 emissions (% of total fuel combustion) in Netherlands in 1974 to that in 1979?
Offer a terse response. 1.08. What is the ratio of the CO2 emissions (% of total fuel combustion) in Philippines in 1974 to that in 1979?
Provide a succinct answer. 1.06. What is the ratio of the CO2 emissions (% of total fuel combustion) of United States in 1974 to that in 1979?
Your response must be concise. 1.02. What is the ratio of the CO2 emissions (% of total fuel combustion) of Netherlands in 1975 to that in 1976?
Provide a short and direct response. 0.97. What is the ratio of the CO2 emissions (% of total fuel combustion) in Philippines in 1975 to that in 1976?
Your answer should be very brief. 0.92. What is the ratio of the CO2 emissions (% of total fuel combustion) in United States in 1975 to that in 1976?
Ensure brevity in your answer.  1.11. What is the ratio of the CO2 emissions (% of total fuel combustion) in Libya in 1975 to that in 1977?
Provide a short and direct response. 1.36. What is the ratio of the CO2 emissions (% of total fuel combustion) of Netherlands in 1975 to that in 1977?
Your response must be concise. 1.14. What is the ratio of the CO2 emissions (% of total fuel combustion) in Philippines in 1975 to that in 1977?
Your response must be concise. 0.98. What is the ratio of the CO2 emissions (% of total fuel combustion) in United States in 1975 to that in 1977?
Give a very brief answer. 1.33. What is the ratio of the CO2 emissions (% of total fuel combustion) in Libya in 1975 to that in 1978?
Your answer should be compact. 0.88. What is the ratio of the CO2 emissions (% of total fuel combustion) of Netherlands in 1975 to that in 1978?
Provide a short and direct response. 1.11. What is the ratio of the CO2 emissions (% of total fuel combustion) in Philippines in 1975 to that in 1978?
Your answer should be very brief. 0.95. What is the ratio of the CO2 emissions (% of total fuel combustion) in United States in 1975 to that in 1978?
Give a very brief answer. 1.34. What is the ratio of the CO2 emissions (% of total fuel combustion) in Libya in 1975 to that in 1979?
Offer a terse response. 0.99. What is the ratio of the CO2 emissions (% of total fuel combustion) of Netherlands in 1975 to that in 1979?
Your answer should be compact. 1.17. What is the ratio of the CO2 emissions (% of total fuel combustion) in Philippines in 1975 to that in 1979?
Make the answer very short. 0.98. What is the ratio of the CO2 emissions (% of total fuel combustion) in United States in 1975 to that in 1979?
Provide a short and direct response. 1.11. What is the ratio of the CO2 emissions (% of total fuel combustion) of Libya in 1976 to that in 1977?
Ensure brevity in your answer.  1.36. What is the ratio of the CO2 emissions (% of total fuel combustion) in Netherlands in 1976 to that in 1977?
Your answer should be compact. 1.18. What is the ratio of the CO2 emissions (% of total fuel combustion) of Philippines in 1976 to that in 1977?
Provide a short and direct response. 1.06. What is the ratio of the CO2 emissions (% of total fuel combustion) of United States in 1976 to that in 1977?
Keep it short and to the point. 1.2. What is the ratio of the CO2 emissions (% of total fuel combustion) of Libya in 1976 to that in 1978?
Provide a short and direct response. 0.87. What is the ratio of the CO2 emissions (% of total fuel combustion) of Netherlands in 1976 to that in 1978?
Your answer should be compact. 1.14. What is the ratio of the CO2 emissions (% of total fuel combustion) of Philippines in 1976 to that in 1978?
Keep it short and to the point. 1.03. What is the ratio of the CO2 emissions (% of total fuel combustion) of United States in 1976 to that in 1978?
Make the answer very short. 1.21. What is the ratio of the CO2 emissions (% of total fuel combustion) in Libya in 1976 to that in 1979?
Your answer should be very brief. 0.99. What is the ratio of the CO2 emissions (% of total fuel combustion) in Netherlands in 1976 to that in 1979?
Your answer should be very brief. 1.2. What is the ratio of the CO2 emissions (% of total fuel combustion) of Philippines in 1976 to that in 1979?
Keep it short and to the point. 1.06. What is the ratio of the CO2 emissions (% of total fuel combustion) in Libya in 1977 to that in 1978?
Keep it short and to the point. 0.64. What is the ratio of the CO2 emissions (% of total fuel combustion) of Netherlands in 1977 to that in 1978?
Your response must be concise. 0.97. What is the ratio of the CO2 emissions (% of total fuel combustion) of Philippines in 1977 to that in 1978?
Provide a succinct answer. 0.97. What is the ratio of the CO2 emissions (% of total fuel combustion) in Libya in 1977 to that in 1979?
Your answer should be very brief. 0.73. What is the ratio of the CO2 emissions (% of total fuel combustion) in Netherlands in 1977 to that in 1979?
Offer a terse response. 1.02. What is the ratio of the CO2 emissions (% of total fuel combustion) in United States in 1977 to that in 1979?
Offer a terse response. 0.83. What is the ratio of the CO2 emissions (% of total fuel combustion) in Libya in 1978 to that in 1979?
Ensure brevity in your answer.  1.13. What is the ratio of the CO2 emissions (% of total fuel combustion) in Netherlands in 1978 to that in 1979?
Offer a very short reply. 1.06. What is the ratio of the CO2 emissions (% of total fuel combustion) of Philippines in 1978 to that in 1979?
Offer a very short reply. 1.03. What is the ratio of the CO2 emissions (% of total fuel combustion) in United States in 1978 to that in 1979?
Provide a short and direct response. 0.83. What is the difference between the highest and the second highest CO2 emissions (% of total fuel combustion) in Libya?
Ensure brevity in your answer.  0.17. What is the difference between the highest and the second highest CO2 emissions (% of total fuel combustion) of Netherlands?
Provide a succinct answer. 0.26. What is the difference between the highest and the second highest CO2 emissions (% of total fuel combustion) in Philippines?
Your answer should be compact. 0.03. What is the difference between the highest and the second highest CO2 emissions (% of total fuel combustion) of United States?
Provide a succinct answer. 0.16. What is the difference between the highest and the lowest CO2 emissions (% of total fuel combustion) in Libya?
Keep it short and to the point. 0.79. What is the difference between the highest and the lowest CO2 emissions (% of total fuel combustion) in Netherlands?
Ensure brevity in your answer.  1.67. What is the difference between the highest and the lowest CO2 emissions (% of total fuel combustion) of Philippines?
Your answer should be compact. 0.84. What is the difference between the highest and the lowest CO2 emissions (% of total fuel combustion) in United States?
Provide a short and direct response. 0.49. 